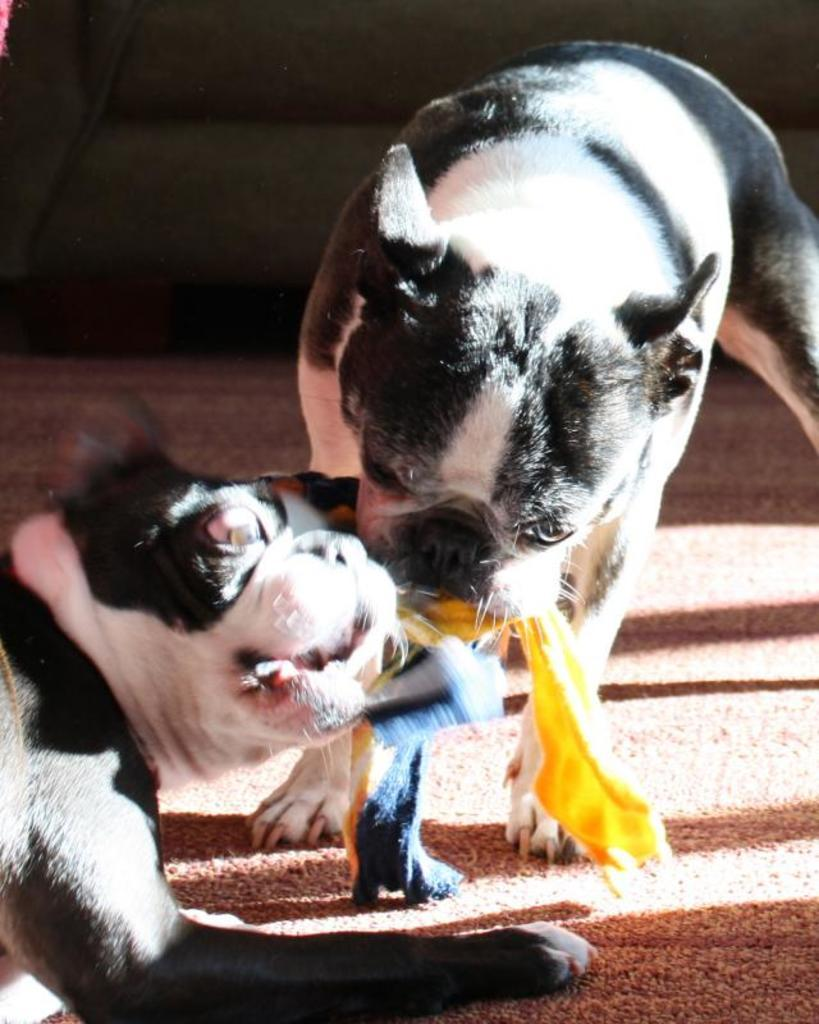How many dogs are present in the image? There are two dogs in the image. Where are the dogs located in the image? The dogs are in the center of the image. What surface are the dogs on? The dogs are on a rug. What type of club does the dog on the left hold in its arm? There is no club or arm present in the image; the dogs are simply standing on a rug. 